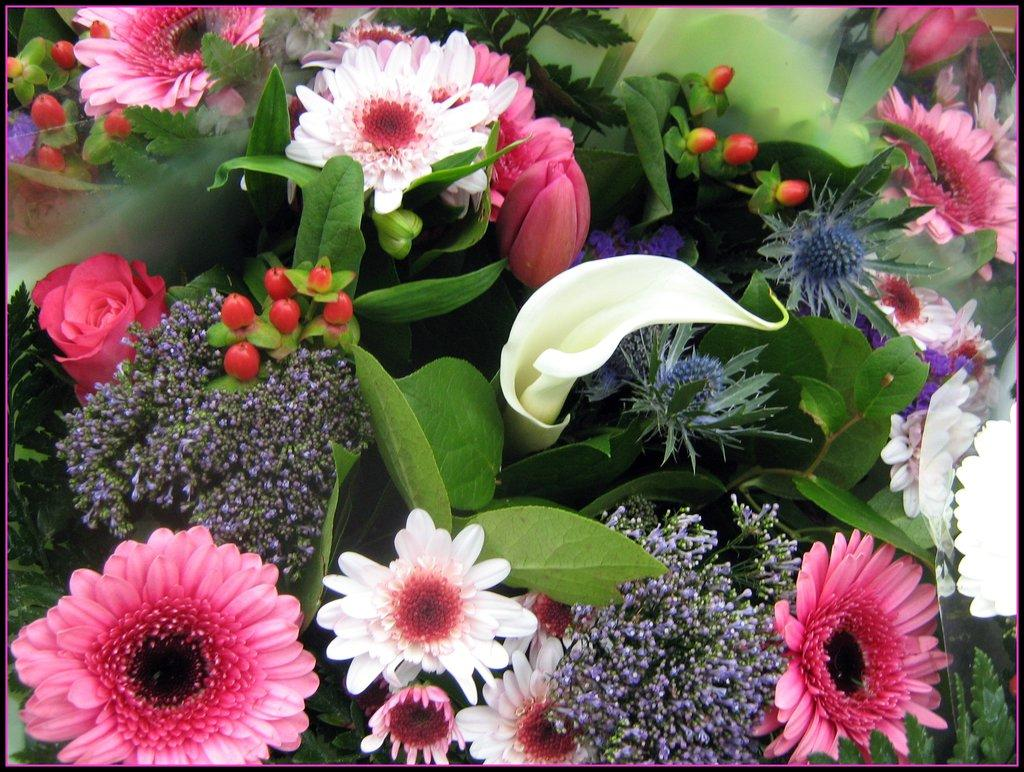What type of plant life can be seen in the image? There are flowers and leaves in the image. Can you describe the flowers in the image? Unfortunately, the facts provided do not give specific details about the flowers. What is the color of the leaves in the image? The facts provided do not specify the color of the leaves. What type of thread is used to sew the jewel onto the flowers in the image? There is no thread or jewel present in the image; it only features flowers and leaves. 